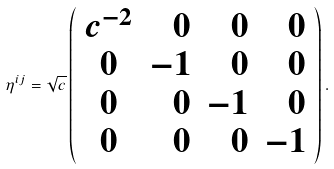Convert formula to latex. <formula><loc_0><loc_0><loc_500><loc_500>\eta ^ { i j } = { { \sqrt { c } } } \left ( \begin{array} { c r r r } c ^ { - 2 } & 0 & 0 & 0 \\ 0 & - 1 & 0 & 0 \\ 0 & 0 & - 1 & 0 \\ 0 & 0 & 0 & - 1 \end{array} \right ) .</formula> 